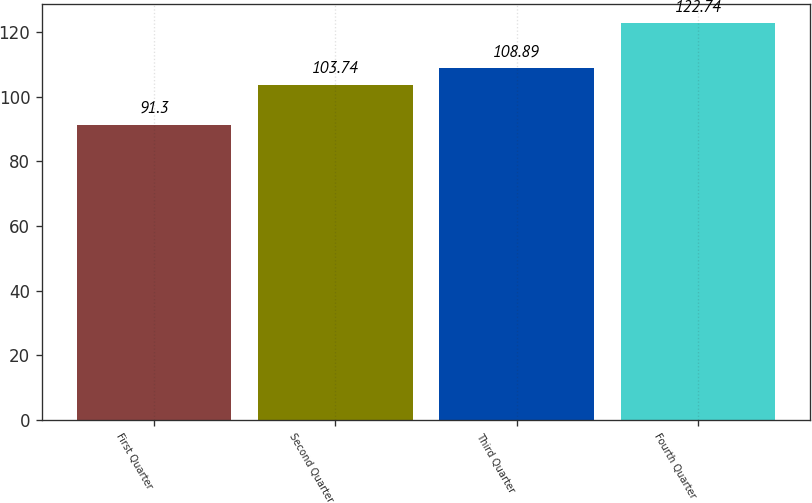Convert chart to OTSL. <chart><loc_0><loc_0><loc_500><loc_500><bar_chart><fcel>First Quarter<fcel>Second Quarter<fcel>Third Quarter<fcel>Fourth Quarter<nl><fcel>91.3<fcel>103.74<fcel>108.89<fcel>122.74<nl></chart> 